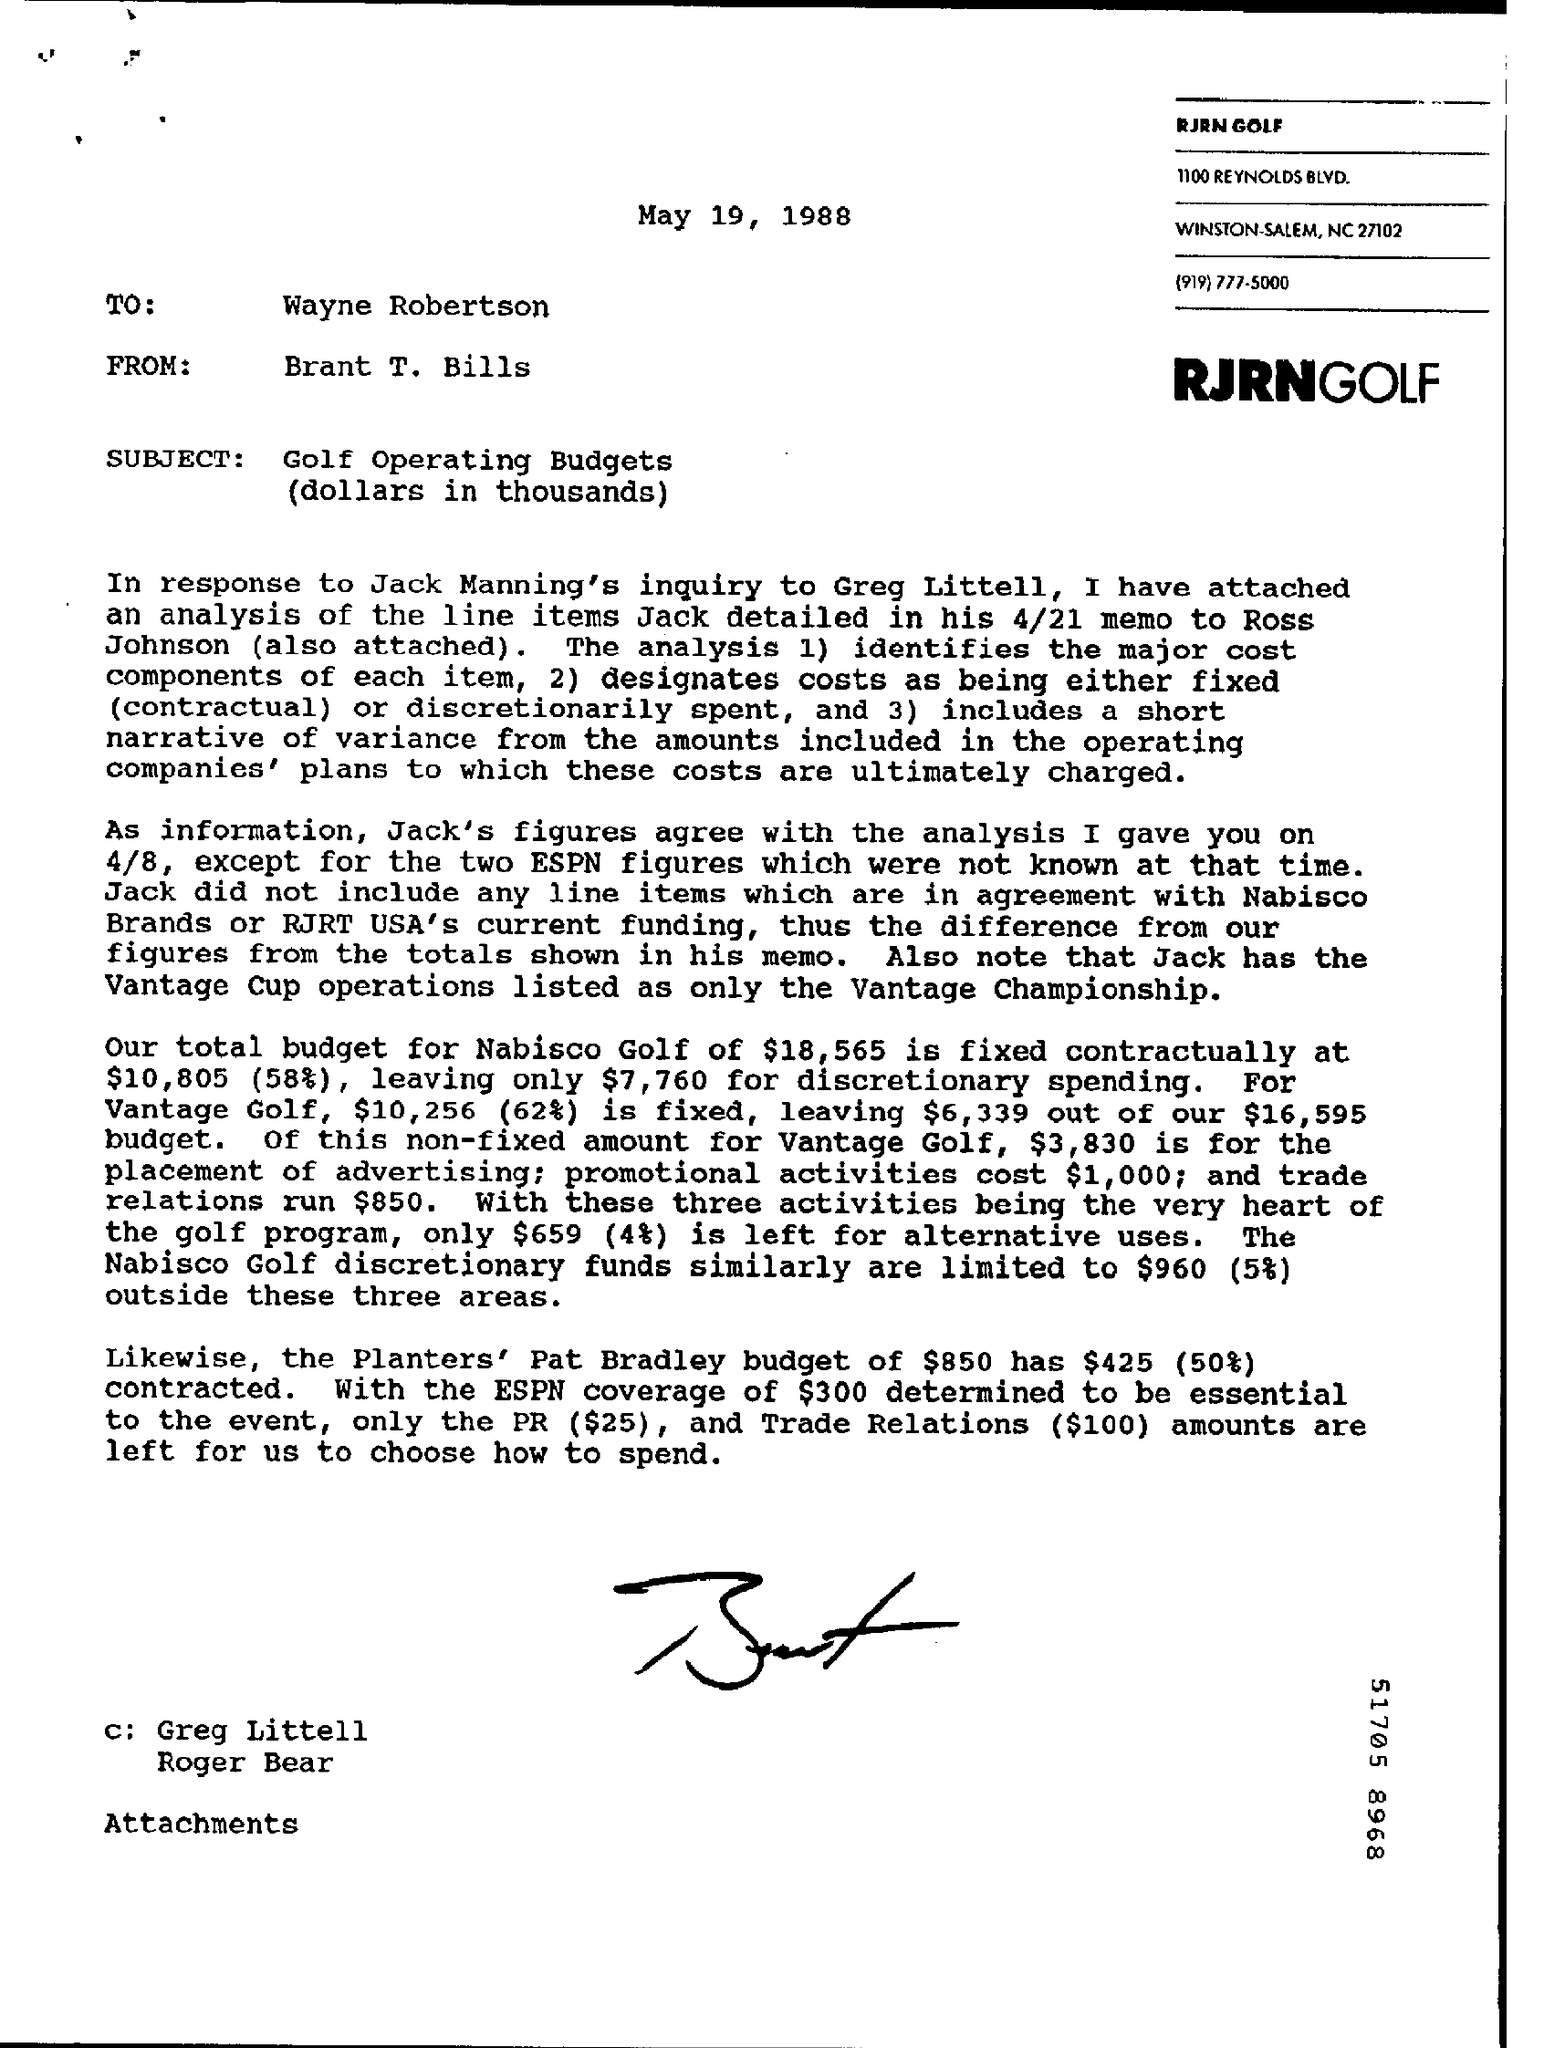What is the Date?
Your answer should be compact. May 19, 1988. To Whom is this letter addressed to?
Offer a terse response. Wayne Robertson. Who is this letter from?
Ensure brevity in your answer.  Brant T. Bills. What is the Total Budget for Nabisco Golf?
Make the answer very short. $18,565. 